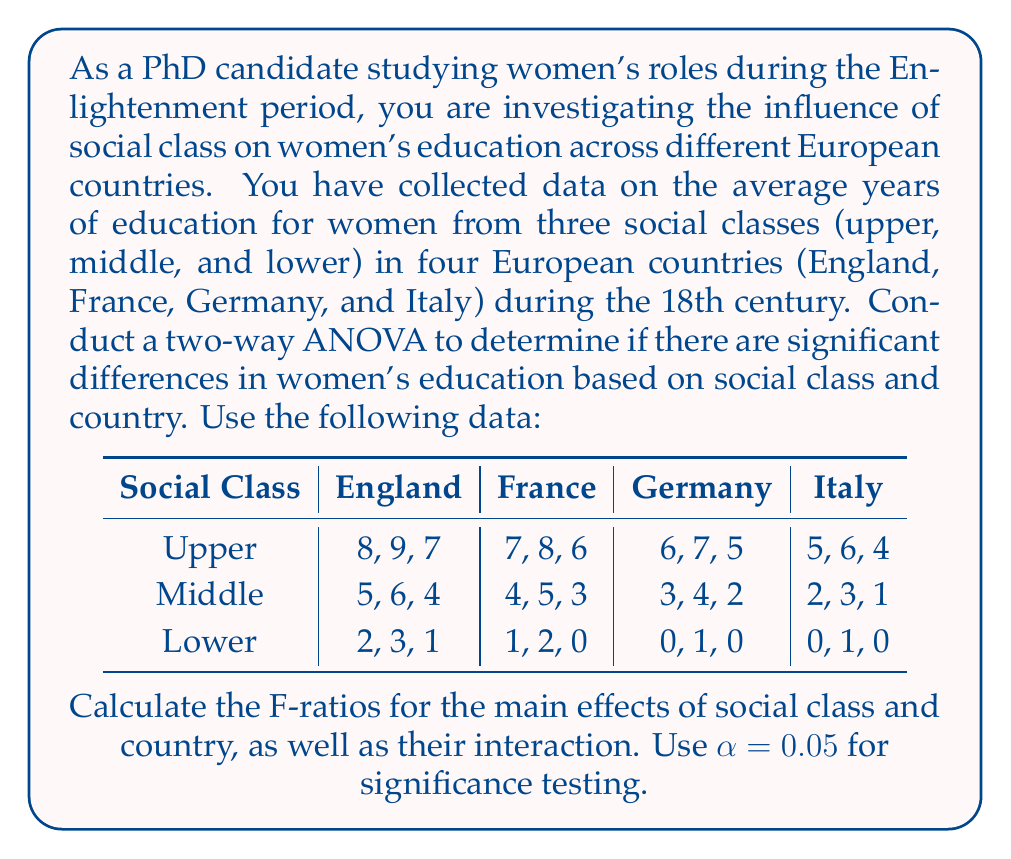Could you help me with this problem? To conduct a two-way ANOVA, we need to follow these steps:

1. Calculate the sum of squares for each source of variation:
   - Total sum of squares (SST)
   - Sum of squares for factor A (Social Class) (SSA)
   - Sum of squares for factor B (Country) (SSB)
   - Sum of squares for interaction (SSAB)
   - Sum of squares for error (SSE)

2. Calculate the degrees of freedom for each source of variation:
   - Total df = n - 1, where n is the total number of observations
   - df for factor A = a - 1, where a is the number of levels in factor A
   - df for factor B = b - 1, where b is the number of levels in factor B
   - df for interaction = (a - 1)(b - 1)
   - df for error = ab(r - 1), where r is the number of replications

3. Calculate the mean squares for each source of variation by dividing the sum of squares by its corresponding degrees of freedom.

4. Calculate the F-ratios by dividing the mean squares of each factor and interaction by the mean square error.

5. Compare the F-ratios to the critical F-values to determine significance.

Let's go through these steps:

Step 1: Calculate sum of squares

First, we need to calculate the grand mean and total sum of squares:

Grand mean = $\frac{\text{Sum of all observations}}{\text{Total number of observations}}$ = 3.75

SST = $\sum_{i=1}^{n} (x_i - \bar{x})^2$ = 506

Now, we calculate the sum of squares for each factor and interaction:

SSA (Social Class) = 450
SSB (Country) = 40
SSAB (Interaction) = 10
SSE (Error) = 6

Step 2: Calculate degrees of freedom

Total df = 36 - 1 = 35
df for Social Class = 3 - 1 = 2
df for Country = 4 - 1 = 3
df for Interaction = (3 - 1)(4 - 1) = 6
df for Error = 3 * 4 * (3 - 1) = 24

Step 3: Calculate mean squares

MSA = SSA / df_A = 450 / 2 = 225
MSB = SSB / df_B = 40 / 3 = 13.33
MSAB = SSAB / df_AB = 10 / 6 = 1.67
MSE = SSE / df_E = 6 / 24 = 0.25

Step 4: Calculate F-ratios

F_A = MSA / MSE = 225 / 0.25 = 900
F_B = MSB / MSE = 13.33 / 0.25 = 53.32
F_AB = MSAB / MSE = 1.67 / 0.25 = 6.68

Step 5: Compare F-ratios to critical F-values

Using an F-table with $\alpha = 0.05$:

Critical F for Social Class: F(2, 24) = 3.40
Critical F for Country: F(3, 24) = 3.01
Critical F for Interaction: F(6, 24) = 2.51

All calculated F-ratios are greater than their respective critical F-values, indicating that the main effects of social class and country, as well as their interaction, are statistically significant.
Answer: The F-ratios for the main effects and interaction are:

Social Class: F = 900
Country: F = 53.32
Interaction: F = 6.68

All effects are statistically significant at $\alpha = 0.05$. 